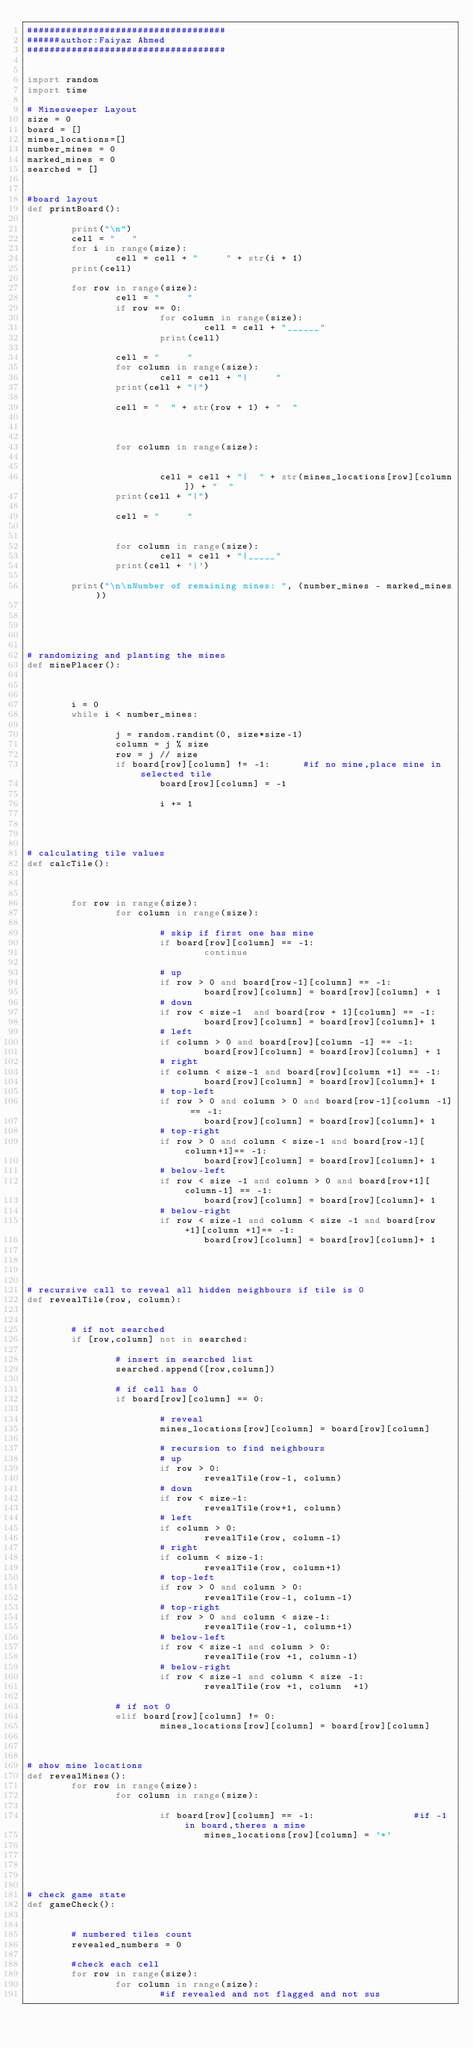Convert code to text. <code><loc_0><loc_0><loc_500><loc_500><_Python_>####################################
######author:Faiyaz Ahmed
####################################


import random
import time

# Minesweeper Layout
size = 0
board = []
mines_locations=[]
number_mines = 0
marked_mines = 0
searched = []


#board layout
def printBoard():

        print("\n")
        cell = "   "
        for i in range(size):
                cell = cell + "     " + str(i + 1)
        print(cell)

        for row in range(size):
                cell = "     "
                if row == 0:
                        for column in range(size):
                                cell = cell + "______"
                        print(cell)

                cell = "     "
                for column in range(size):
                        cell = cell + "|     "
                print(cell + "|")

                cell = "  " + str(row + 1) + "  "



                for column in range(size):


                        cell = cell + "|  " + str(mines_locations[row][column]) + "  "
                print(cell + "|")

                cell = "     "


                for column in range(size):
                        cell = cell + "|_____"
                print(cell + '|')

        print("\n\nNumber of remaining mines: ", (number_mines - marked_mines))





# randomizing and planting the mines
def minePlacer():



        i = 0
        while i < number_mines:

                j = random.randint(0, size*size-1)
                column = j % size
                row = j // size
                if board[row][column] != -1:      #if no mine,place mine in selected tile
                        board[row][column] = -1

                        i += 1




# calculating tile values
def calcTile():



        for row in range(size):
                for column in range(size):

                        # skip if first one has mine
                        if board[row][column] == -1:
                                continue

                        # up
                        if row > 0 and board[row-1][column] == -1:
                                board[row][column] = board[row][column] + 1
                        # down
                        if row < size-1  and board[row + 1][column] == -1:
                                board[row][column] = board[row][column]+ 1
                        # left
                        if column > 0 and board[row][column -1] == -1:
                                board[row][column] = board[row][column] + 1
                        # right
                        if column < size-1 and board[row][column +1] == -1:
                                board[row][column] = board[row][column]+ 1
                        # top-left
                        if row > 0 and column > 0 and board[row-1][column -1] == -1:
                                board[row][column] = board[row][column]+ 1
                        # top-right
                        if row > 0 and column < size-1 and board[row-1][column+1]== -1:
                                board[row][column] = board[row][column]+ 1
                        # below-left
                        if row < size -1 and column > 0 and board[row+1][column-1] == -1:
                                board[row][column] = board[row][column]+ 1
                        # below-right
                        if row < size-1 and column < size -1 and board[row+1][column +1]== -1:
                                board[row][column] = board[row][column]+ 1




# recursive call to reveal all hidden neighbours if tile is 0
def revealTile(row, column):


        # if not searched
        if [row,column] not in searched:

                # insert in searched list
                searched.append([row,column])

                # if cell has 0
                if board[row][column] == 0:

                        # reveal
                        mines_locations[row][column] = board[row][column]

                        # recursion to find neighbours
                        # up
                        if row > 0:
                                revealTile(row-1, column)
                        # down
                        if row < size-1:
                                revealTile(row+1, column)
                        # left
                        if column > 0:
                                revealTile(row, column-1)
                        # right
                        if column < size-1:
                                revealTile(row, column+1)
                        # top-left
                        if row > 0 and column > 0:
                                revealTile(row-1, column-1)
                        # top-right
                        if row > 0 and column < size-1:
                                revealTile(row-1, column+1)
                        # below-left
                        if row < size-1 and column > 0:
                                revealTile(row +1, column-1)
                        # below-right
                        if row < size-1 and column < size -1:
                                revealTile(row +1, column  +1)

                # if not 0
                elif board[row][column] != 0:
                        mines_locations[row][column] = board[row][column]



# show mine locations
def revealMines():
        for row in range(size):
                for column in range(size):

                        if board[row][column] == -1:                  #if -1 in board,theres a mine
                                mines_locations[row][column] = '*'





# check game state
def gameCheck():


        # numbered tiles count
        revealed_numbers = 0

        #check each cell
        for row in range(size):
                for column in range(size):
                        #if revealed and not flagged and not sus</code> 